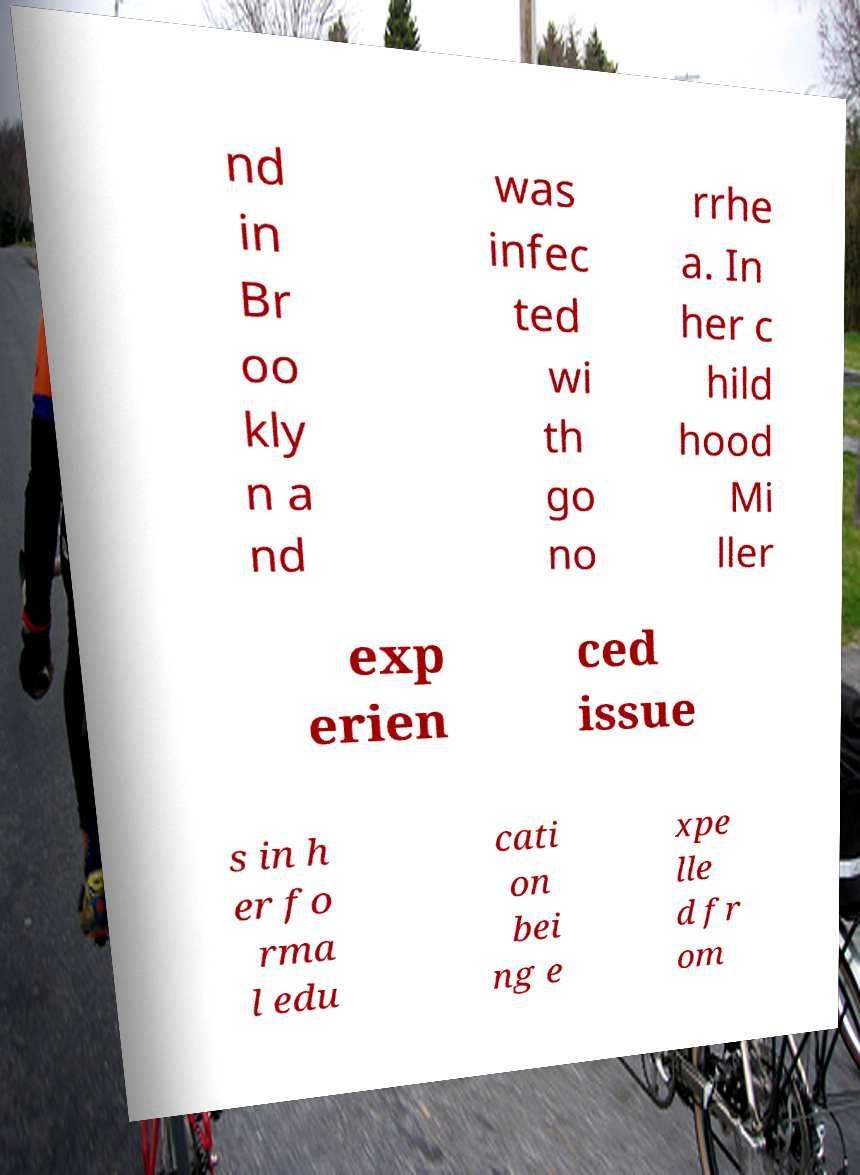What messages or text are displayed in this image? I need them in a readable, typed format. nd in Br oo kly n a nd was infec ted wi th go no rrhe a. In her c hild hood Mi ller exp erien ced issue s in h er fo rma l edu cati on bei ng e xpe lle d fr om 